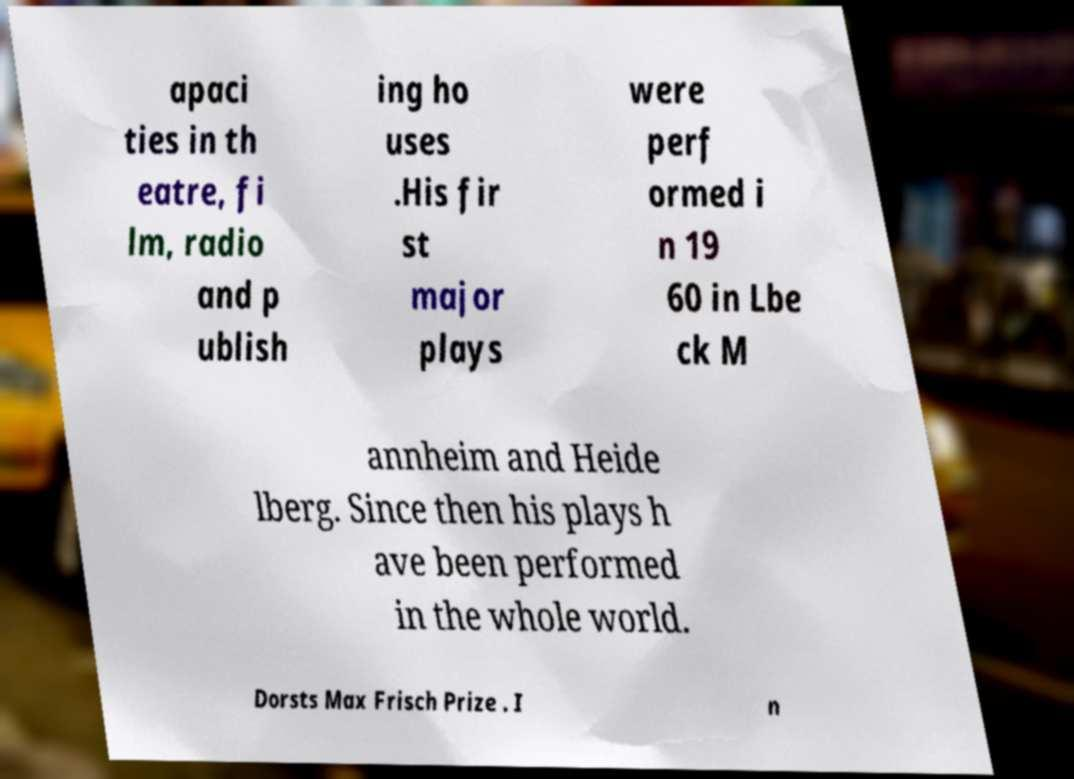Can you accurately transcribe the text from the provided image for me? apaci ties in th eatre, fi lm, radio and p ublish ing ho uses .His fir st major plays were perf ormed i n 19 60 in Lbe ck M annheim and Heide lberg. Since then his plays h ave been performed in the whole world. Dorsts Max Frisch Prize . I n 